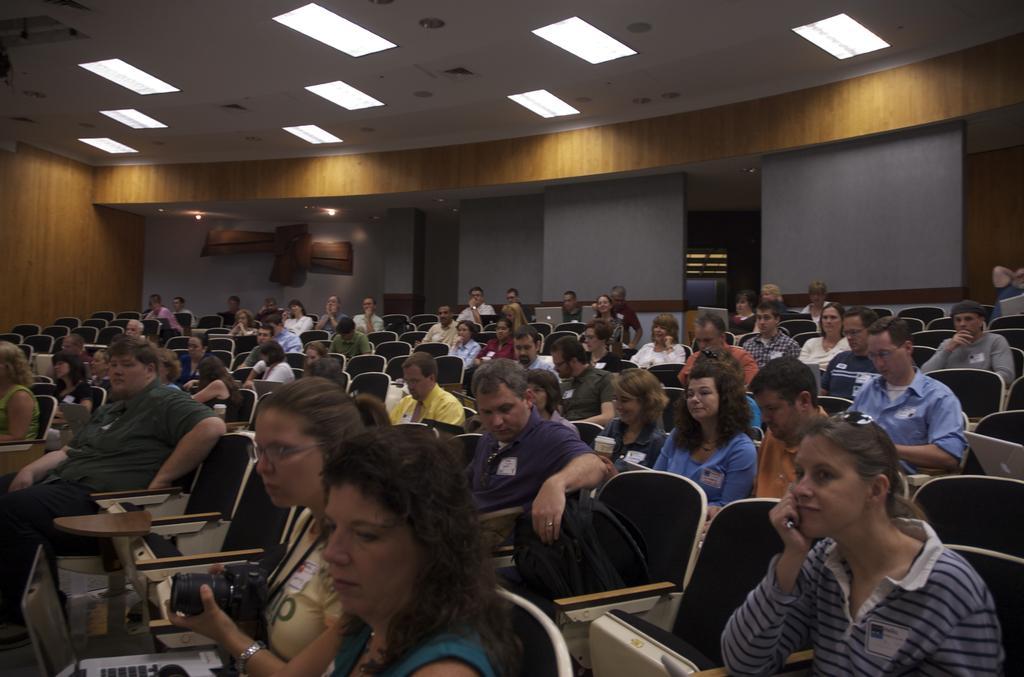How would you summarize this image in a sentence or two? In the image few people are sitting on the chairs. Behind them there is a wall. At the top of the image there is a roof and lights. 